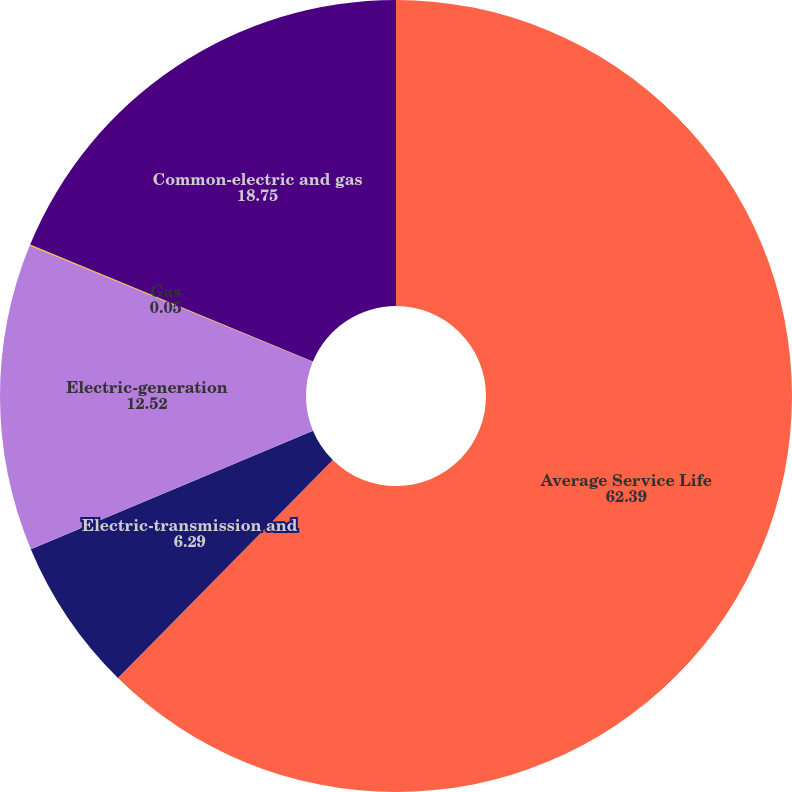<chart> <loc_0><loc_0><loc_500><loc_500><pie_chart><fcel>Average Service Life<fcel>Electric-transmission and<fcel>Electric-generation<fcel>Gas<fcel>Common-electric and gas<nl><fcel>62.39%<fcel>6.29%<fcel>12.52%<fcel>0.05%<fcel>18.75%<nl></chart> 